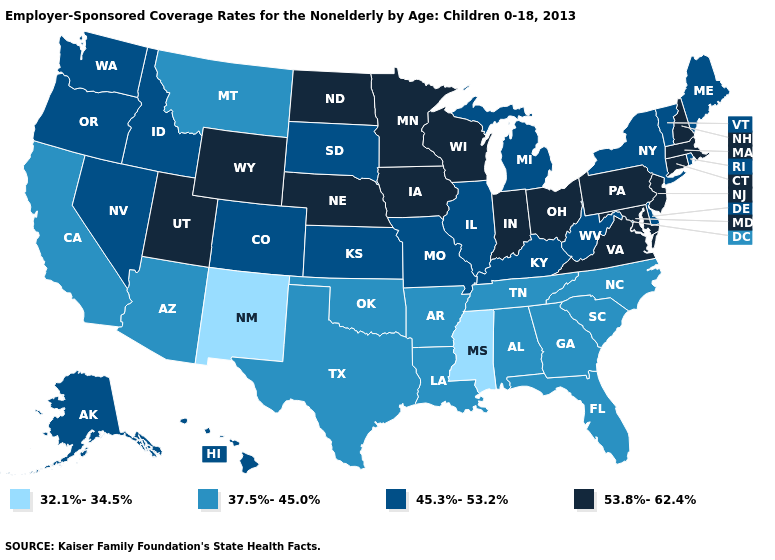What is the lowest value in the Northeast?
Concise answer only. 45.3%-53.2%. Name the states that have a value in the range 53.8%-62.4%?
Be succinct. Connecticut, Indiana, Iowa, Maryland, Massachusetts, Minnesota, Nebraska, New Hampshire, New Jersey, North Dakota, Ohio, Pennsylvania, Utah, Virginia, Wisconsin, Wyoming. Is the legend a continuous bar?
Be succinct. No. Does Maine have the highest value in the Northeast?
Write a very short answer. No. Name the states that have a value in the range 37.5%-45.0%?
Answer briefly. Alabama, Arizona, Arkansas, California, Florida, Georgia, Louisiana, Montana, North Carolina, Oklahoma, South Carolina, Tennessee, Texas. Name the states that have a value in the range 53.8%-62.4%?
Keep it brief. Connecticut, Indiana, Iowa, Maryland, Massachusetts, Minnesota, Nebraska, New Hampshire, New Jersey, North Dakota, Ohio, Pennsylvania, Utah, Virginia, Wisconsin, Wyoming. What is the value of Rhode Island?
Concise answer only. 45.3%-53.2%. Which states have the lowest value in the MidWest?
Short answer required. Illinois, Kansas, Michigan, Missouri, South Dakota. Does Wisconsin have the same value as Washington?
Give a very brief answer. No. Is the legend a continuous bar?
Answer briefly. No. Name the states that have a value in the range 45.3%-53.2%?
Give a very brief answer. Alaska, Colorado, Delaware, Hawaii, Idaho, Illinois, Kansas, Kentucky, Maine, Michigan, Missouri, Nevada, New York, Oregon, Rhode Island, South Dakota, Vermont, Washington, West Virginia. What is the value of New Jersey?
Quick response, please. 53.8%-62.4%. Which states have the highest value in the USA?
Short answer required. Connecticut, Indiana, Iowa, Maryland, Massachusetts, Minnesota, Nebraska, New Hampshire, New Jersey, North Dakota, Ohio, Pennsylvania, Utah, Virginia, Wisconsin, Wyoming. Does Alabama have the same value as Washington?
Answer briefly. No. What is the value of New Mexico?
Keep it brief. 32.1%-34.5%. 